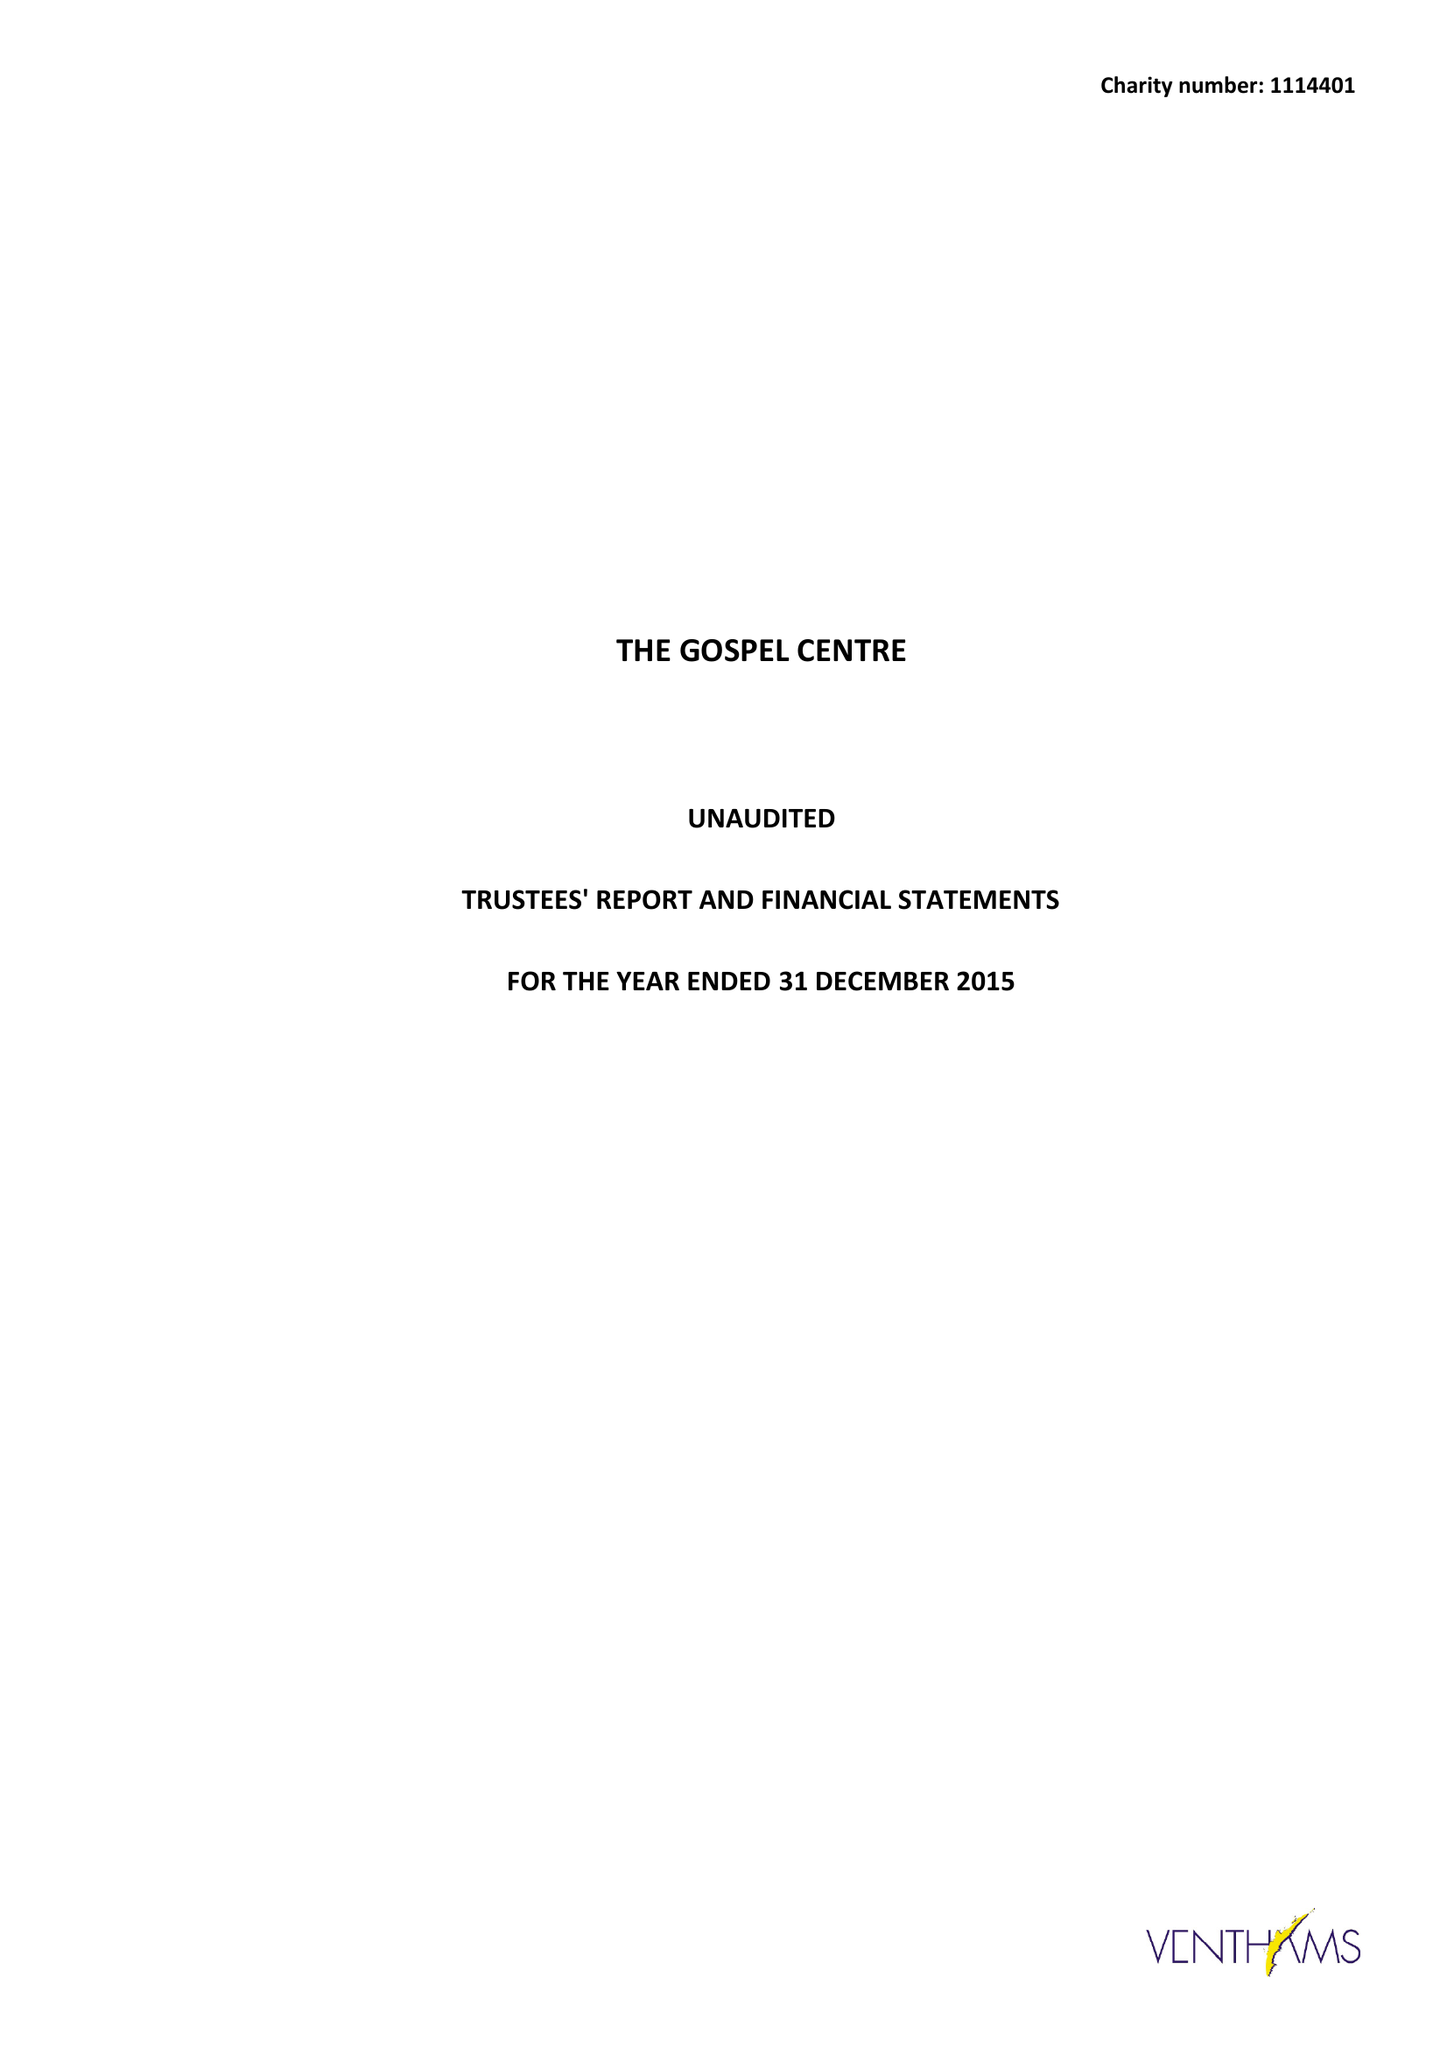What is the value for the spending_annually_in_british_pounds?
Answer the question using a single word or phrase. 130283.00 